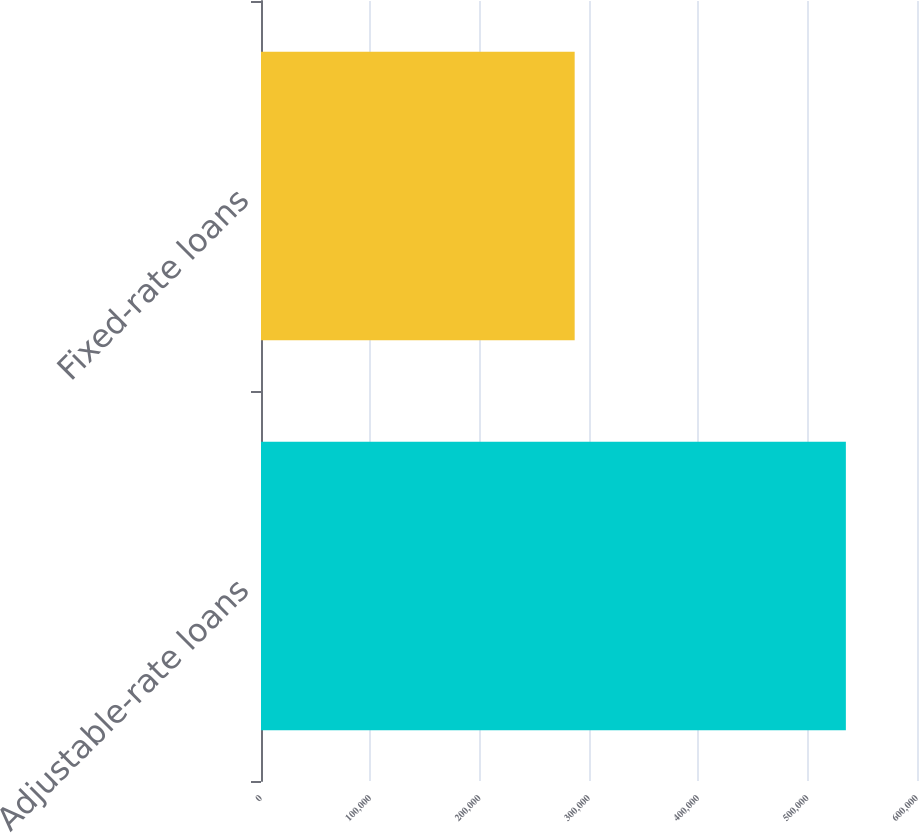<chart> <loc_0><loc_0><loc_500><loc_500><bar_chart><fcel>Adjustable-rate loans<fcel>Fixed-rate loans<nl><fcel>534943<fcel>286894<nl></chart> 